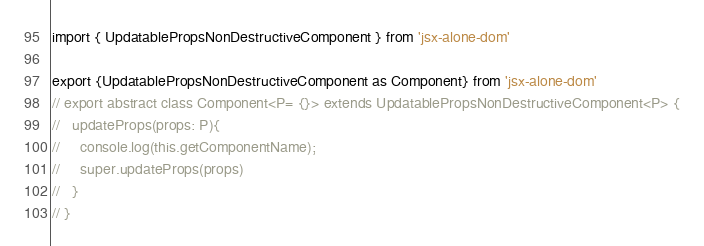<code> <loc_0><loc_0><loc_500><loc_500><_TypeScript_>import { UpdatablePropsNonDestructiveComponent } from 'jsx-alone-dom'

export {UpdatablePropsNonDestructiveComponent as Component} from 'jsx-alone-dom'
// export abstract class Component<P= {}> extends UpdatablePropsNonDestructiveComponent<P> {
//   updateProps(props: P){
//     console.log(this.getComponentName);
//     super.updateProps(props)
//   }
// }
</code> 